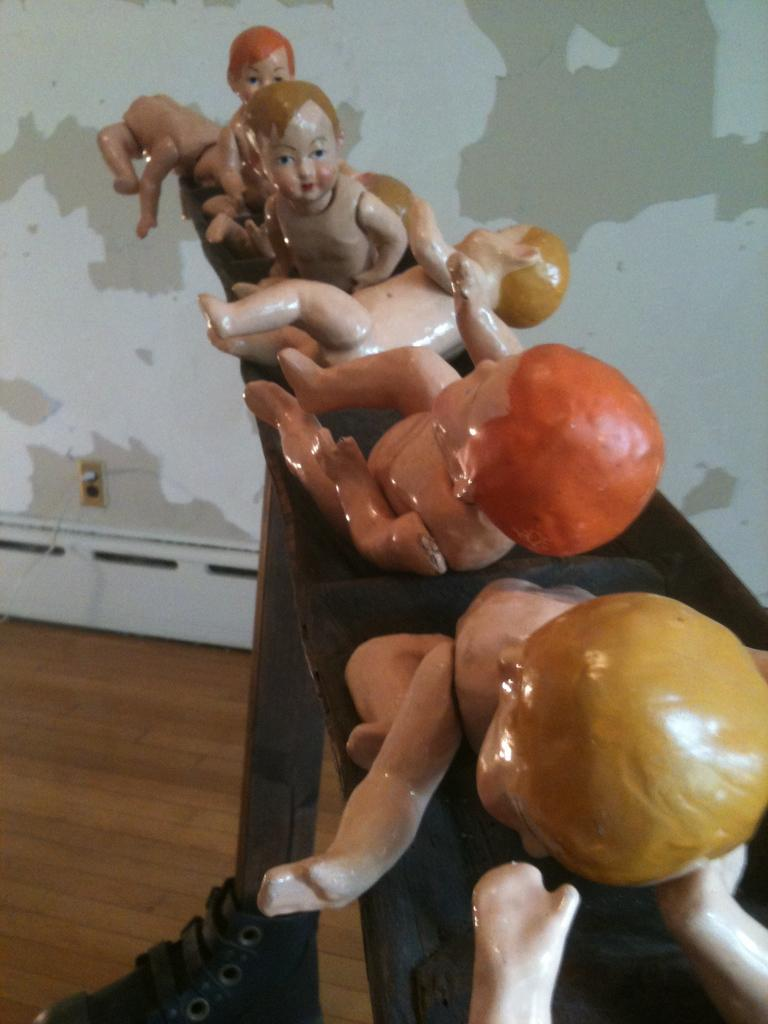What type of statues are in the image? There are kids statues in the image. What color is the floor in the image? The floor is brown in color. What can be seen in the background of the image? There is a wall in the background of the image. How many dogs are present in the image? There are no dogs present in the image; it features kids statues and a brown floor with a wall in the background. 